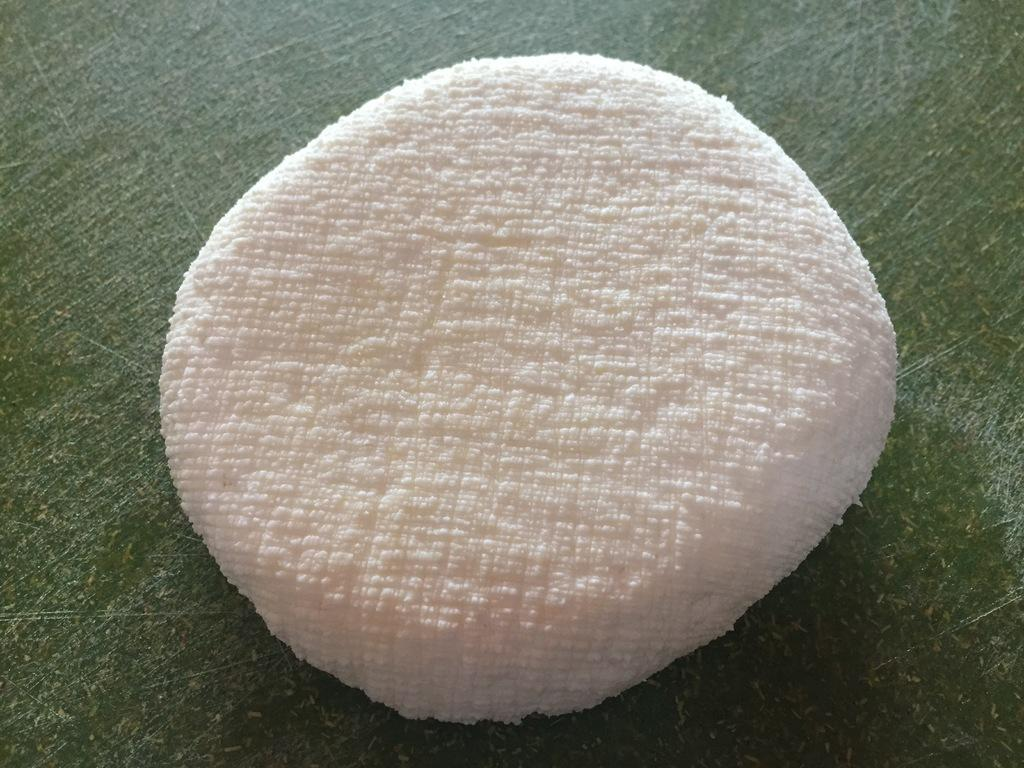What color is the cloth that is visible in the image? The cloth is white in the image. Where is the cloth located in the image? The cloth is on a table in the image. Who is the representative of the cloth in the image? There is no representative of the cloth in the image, as it is an inanimate object. 